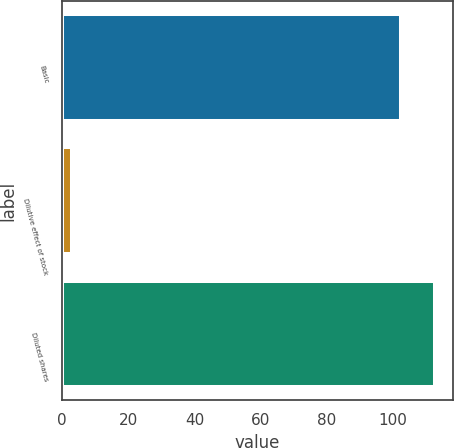<chart> <loc_0><loc_0><loc_500><loc_500><bar_chart><fcel>Basic<fcel>Dilutive effect of stock<fcel>Diluted shares<nl><fcel>102.3<fcel>2.9<fcel>112.53<nl></chart> 